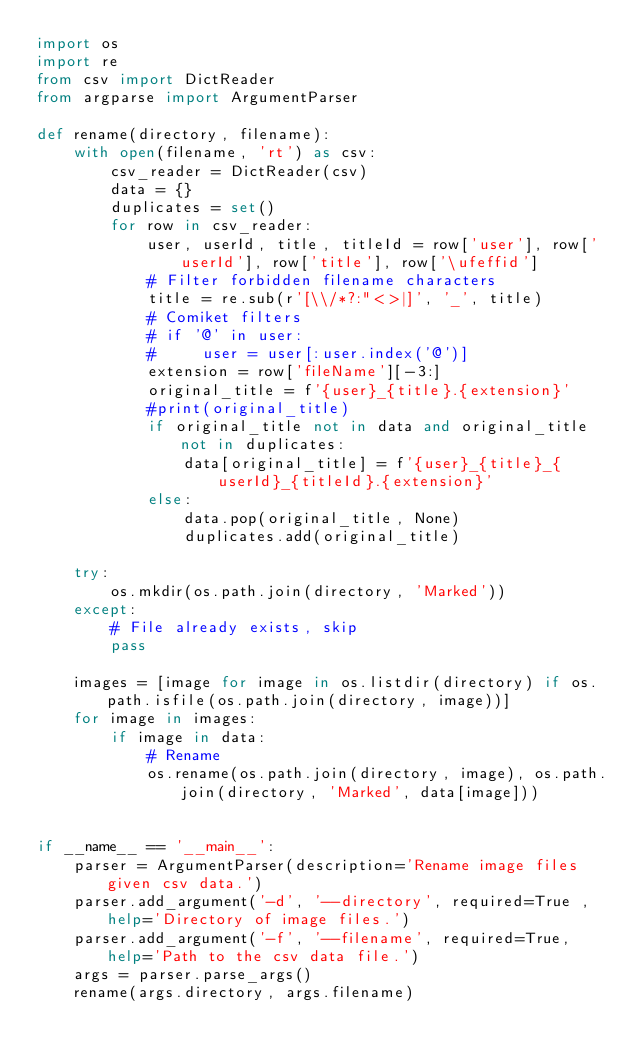<code> <loc_0><loc_0><loc_500><loc_500><_Python_>import os
import re
from csv import DictReader
from argparse import ArgumentParser

def rename(directory, filename):
    with open(filename, 'rt') as csv:
        csv_reader = DictReader(csv)
        data = {}
        duplicates = set()
        for row in csv_reader:
            user, userId, title, titleId = row['user'], row['userId'], row['title'], row['\ufeffid']
            # Filter forbidden filename characters
            title = re.sub(r'[\\/*?:"<>|]', '_', title)
            # Comiket filters
            # if '@' in user:
            #     user = user[:user.index('@')]
            extension = row['fileName'][-3:]
            original_title = f'{user}_{title}.{extension}'
            #print(original_title)
            if original_title not in data and original_title not in duplicates:
                data[original_title] = f'{user}_{title}_{userId}_{titleId}.{extension}'
            else:
                data.pop(original_title, None)
                duplicates.add(original_title)

    try:
        os.mkdir(os.path.join(directory, 'Marked'))
    except:
        # File already exists, skip
        pass

    images = [image for image in os.listdir(directory) if os.path.isfile(os.path.join(directory, image))]
    for image in images:
        if image in data:
            # Rename
            os.rename(os.path.join(directory, image), os.path.join(directory, 'Marked', data[image]))


if __name__ == '__main__':
    parser = ArgumentParser(description='Rename image files given csv data.')
    parser.add_argument('-d', '--directory', required=True ,help='Directory of image files.')
    parser.add_argument('-f', '--filename', required=True, help='Path to the csv data file.')
    args = parser.parse_args()
    rename(args.directory, args.filename)</code> 